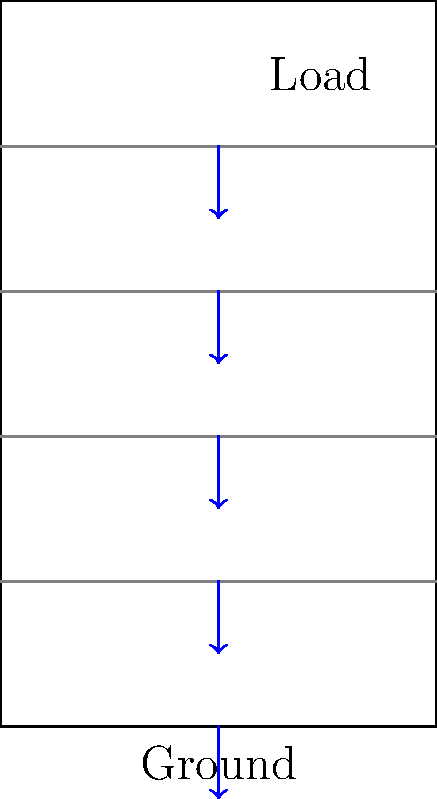In a 5-story building, how does the structural load distribution change from the top floor to the ground level, and what implications does this have for the design of lower-level structural elements? To understand the load distribution in a multi-story building, we need to consider the following steps:

1. Identify load types:
   - Dead loads (constant, e.g., building materials)
   - Live loads (variable, e.g., occupants, furniture)

2. Load accumulation:
   - Each floor supports its own load plus the loads from all floors above it.
   - The load increases cumulatively from top to bottom.

3. Load distribution calculation:
   Let $L_i$ be the load on floor $i$, where $i=1$ is the top floor and $i=5$ is the ground floor.
   Total load on floor $i$: $T_i = \sum_{j=1}^i L_j$

4. Cumulative effect:
   $T_5 > T_4 > T_3 > T_2 > T_1$

5. Structural implications:
   - Lower floors require stronger support elements (e.g., columns, beams).
   - Foundation must be designed to bear the total building load.

6. Design considerations:
   - Increase column sizes or reinforcement in lower floors.
   - Use stronger materials or larger cross-sections for lower-level beams.
   - Design a robust foundation system to distribute the total load to the ground.

7. Safety factors:
   - Incorporate safety factors to account for potential overloading.
   - Typically, use a factor of 1.2 for dead loads and 1.6 for live loads.

8. Code compliance:
   - Ensure design meets local building codes and standards for load-bearing capacity.

This cumulative load distribution is crucial for ensuring the structural integrity and safety of multi-story buildings.
Answer: Load increases cumulatively from top to bottom, requiring stronger structural elements and foundations at lower levels. 